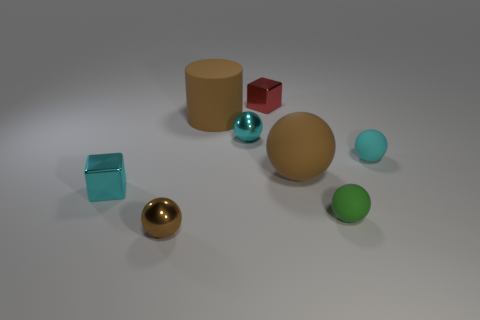Are there any large spheres that have the same color as the big matte cylinder?
Provide a short and direct response. Yes. How many green spheres are left of the cyan thing in front of the brown matte ball?
Ensure brevity in your answer.  0. There is a red shiny object that is behind the big brown matte object left of the big object in front of the tiny cyan matte ball; what shape is it?
Keep it short and to the point. Cube. The matte sphere that is the same color as the large matte cylinder is what size?
Make the answer very short. Large. What number of objects are either big yellow balls or big cylinders?
Provide a short and direct response. 1. The other block that is the same size as the red metallic cube is what color?
Provide a succinct answer. Cyan. Do the green matte thing and the big matte thing on the left side of the tiny red shiny thing have the same shape?
Your response must be concise. No. What number of things are either cyan things that are to the left of the brown cylinder or large brown things on the left side of the small red thing?
Make the answer very short. 2. The big object that is the same color as the large ball is what shape?
Ensure brevity in your answer.  Cylinder. What is the shape of the large brown thing to the left of the red metallic cube?
Give a very brief answer. Cylinder. 